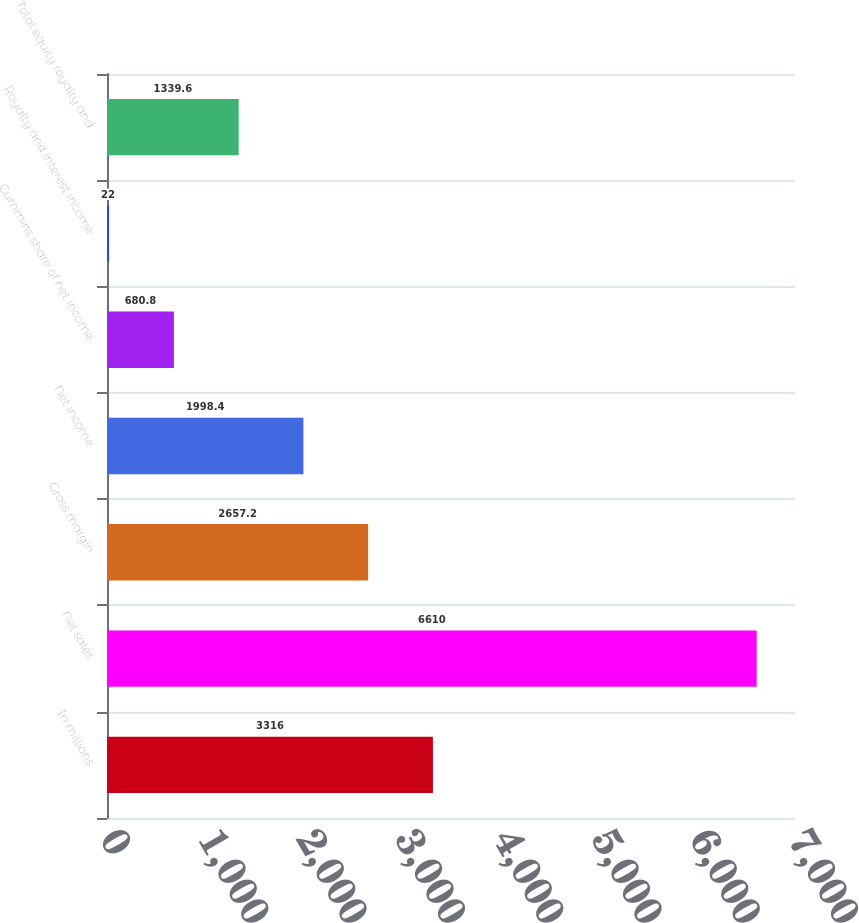Convert chart to OTSL. <chart><loc_0><loc_0><loc_500><loc_500><bar_chart><fcel>In millions<fcel>Net sales<fcel>Gross margin<fcel>Net income<fcel>Cummins share of net income<fcel>Royalty and interest income<fcel>Total equity royalty and<nl><fcel>3316<fcel>6610<fcel>2657.2<fcel>1998.4<fcel>680.8<fcel>22<fcel>1339.6<nl></chart> 